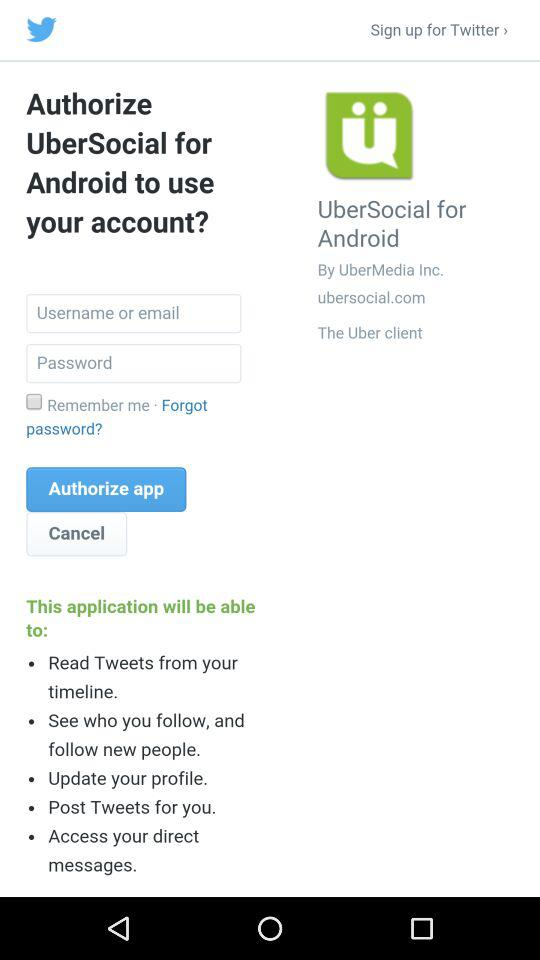How many text inputs are there that require a username or email?
Answer the question using a single word or phrase. 1 